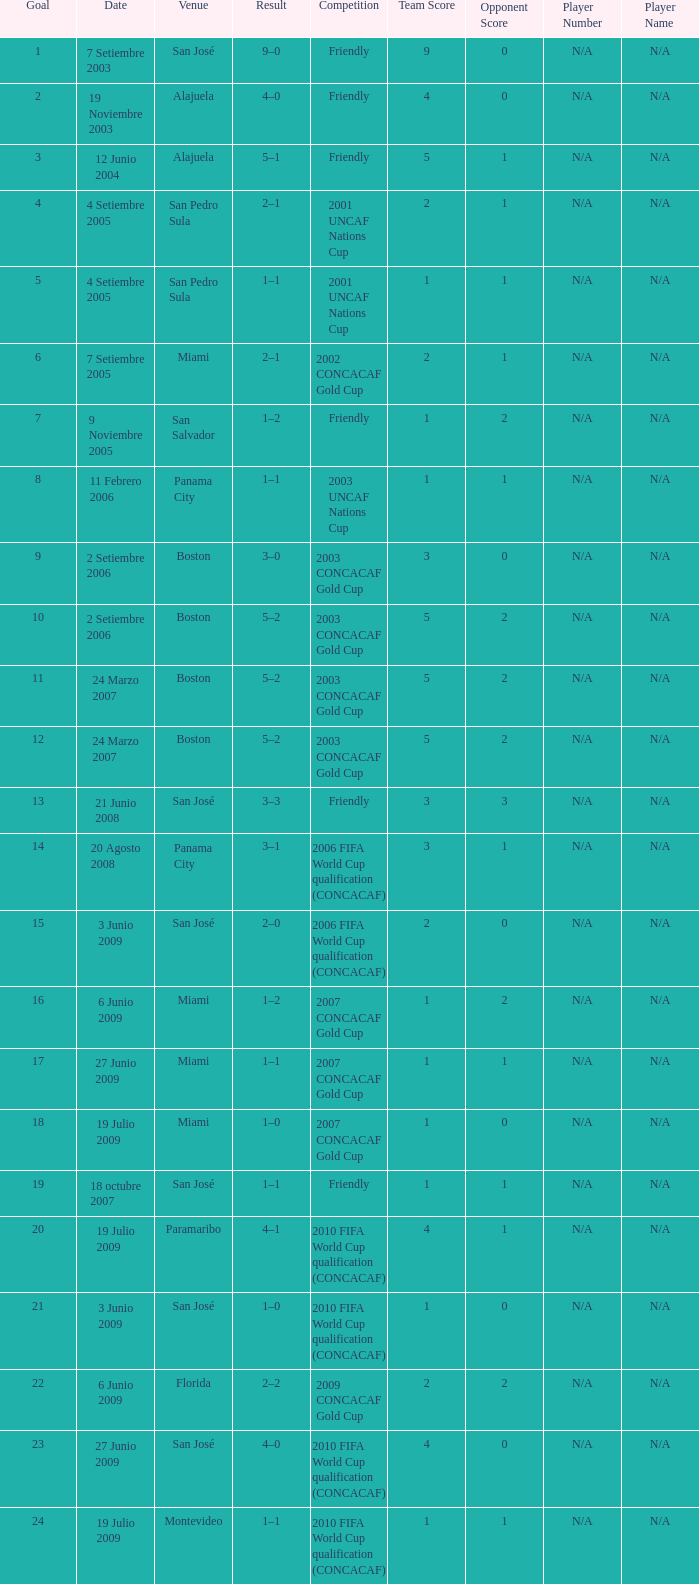How was the competition in which 6 goals were made? 2002 CONCACAF Gold Cup. 